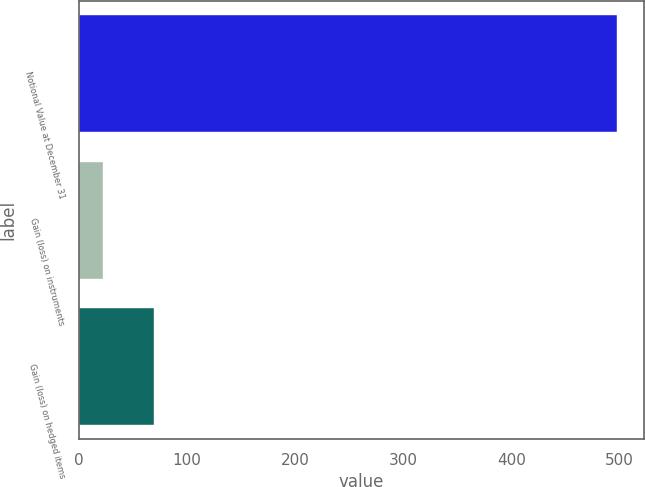<chart> <loc_0><loc_0><loc_500><loc_500><bar_chart><fcel>Notional Value at December 31<fcel>Gain (loss) on instruments<fcel>Gain (loss) on hedged items<nl><fcel>498<fcel>22<fcel>69.6<nl></chart> 